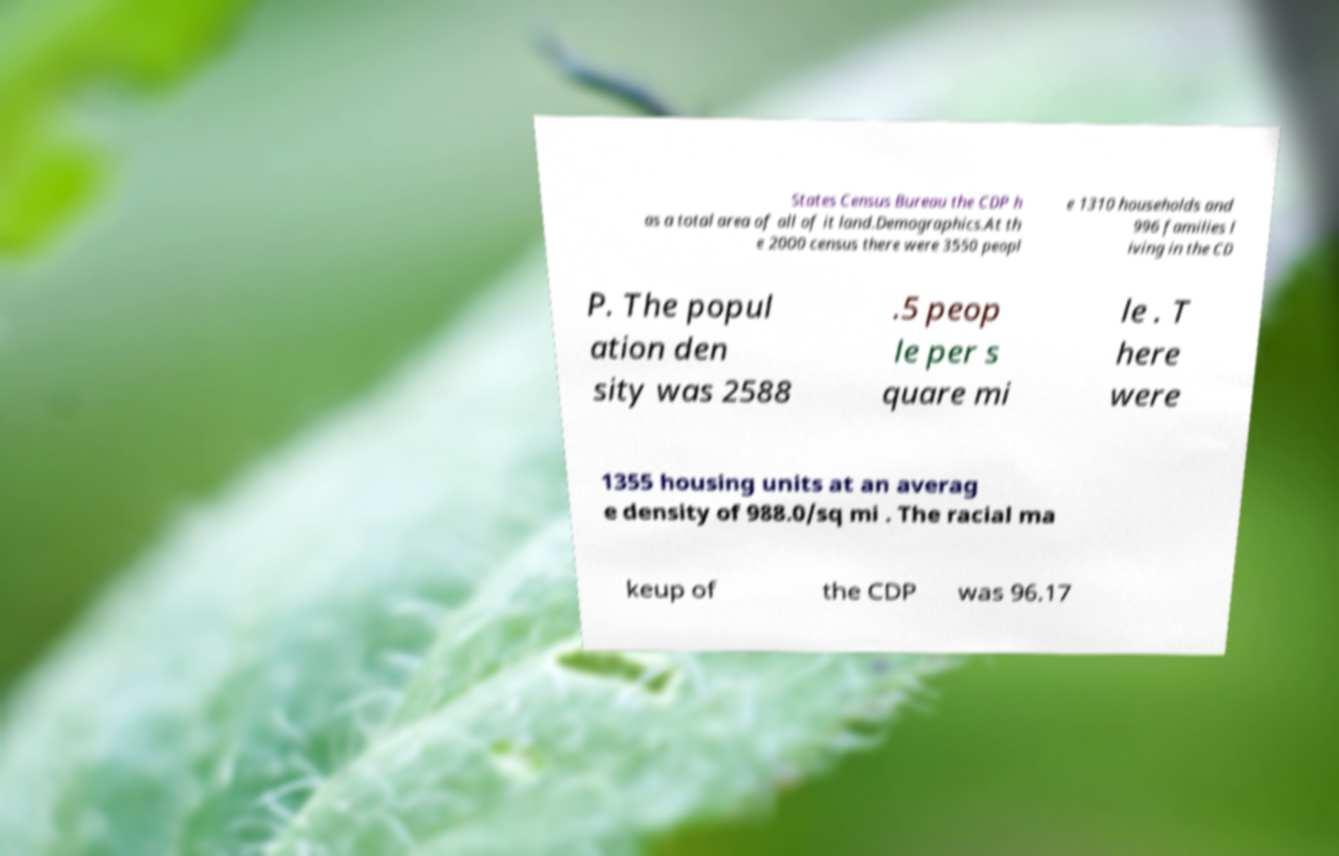Could you extract and type out the text from this image? States Census Bureau the CDP h as a total area of all of it land.Demographics.At th e 2000 census there were 3550 peopl e 1310 households and 996 families l iving in the CD P. The popul ation den sity was 2588 .5 peop le per s quare mi le . T here were 1355 housing units at an averag e density of 988.0/sq mi . The racial ma keup of the CDP was 96.17 